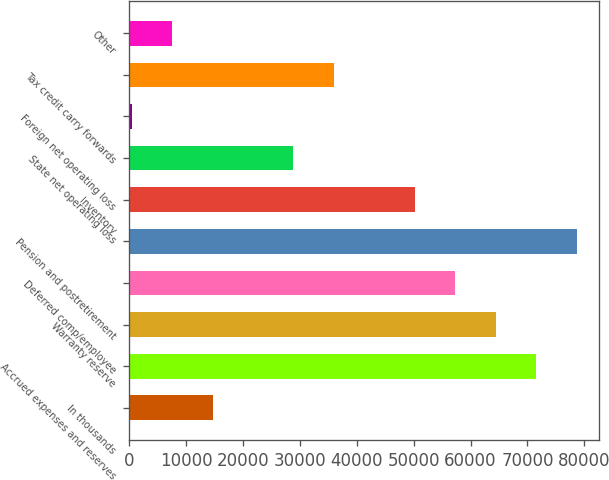Convert chart. <chart><loc_0><loc_0><loc_500><loc_500><bar_chart><fcel>In thousands<fcel>Accrued expenses and reserves<fcel>Warranty reserve<fcel>Deferred comp/employee<fcel>Pension and postretirement<fcel>Inventory<fcel>State net operating loss<fcel>Foreign net operating loss<fcel>Tax credit carry forwards<fcel>Other<nl><fcel>14640<fcel>71516<fcel>64406.5<fcel>57297<fcel>78625.5<fcel>50187.5<fcel>28859<fcel>421<fcel>35968.5<fcel>7530.5<nl></chart> 